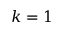<formula> <loc_0><loc_0><loc_500><loc_500>k = 1</formula> 